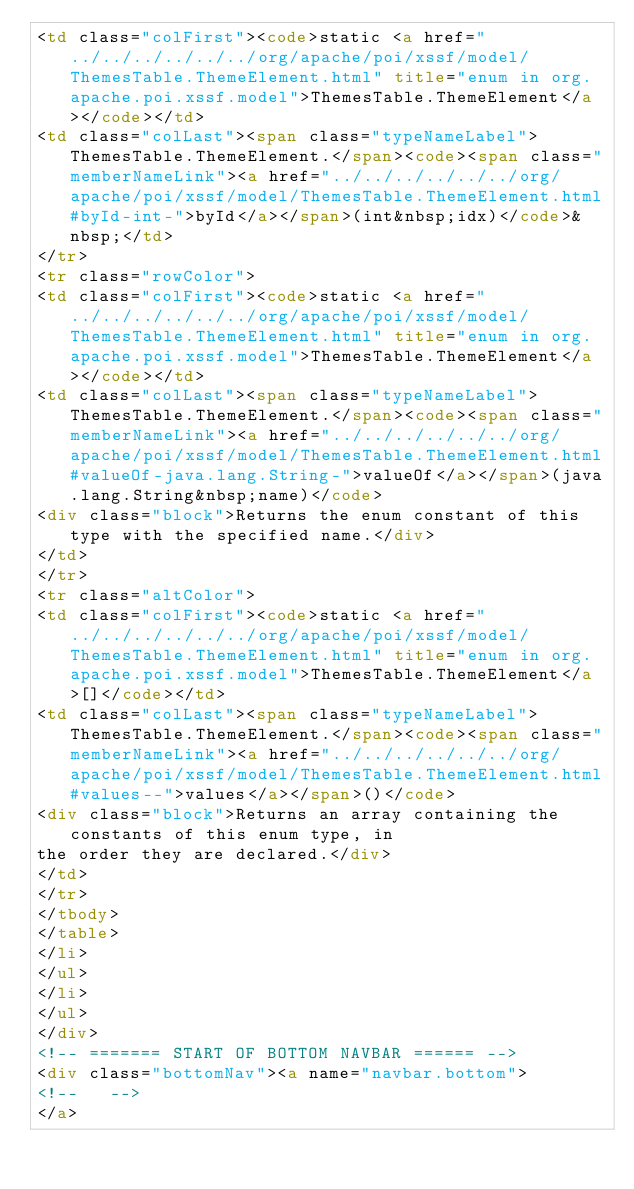Convert code to text. <code><loc_0><loc_0><loc_500><loc_500><_HTML_><td class="colFirst"><code>static <a href="../../../../../../org/apache/poi/xssf/model/ThemesTable.ThemeElement.html" title="enum in org.apache.poi.xssf.model">ThemesTable.ThemeElement</a></code></td>
<td class="colLast"><span class="typeNameLabel">ThemesTable.ThemeElement.</span><code><span class="memberNameLink"><a href="../../../../../../org/apache/poi/xssf/model/ThemesTable.ThemeElement.html#byId-int-">byId</a></span>(int&nbsp;idx)</code>&nbsp;</td>
</tr>
<tr class="rowColor">
<td class="colFirst"><code>static <a href="../../../../../../org/apache/poi/xssf/model/ThemesTable.ThemeElement.html" title="enum in org.apache.poi.xssf.model">ThemesTable.ThemeElement</a></code></td>
<td class="colLast"><span class="typeNameLabel">ThemesTable.ThemeElement.</span><code><span class="memberNameLink"><a href="../../../../../../org/apache/poi/xssf/model/ThemesTable.ThemeElement.html#valueOf-java.lang.String-">valueOf</a></span>(java.lang.String&nbsp;name)</code>
<div class="block">Returns the enum constant of this type with the specified name.</div>
</td>
</tr>
<tr class="altColor">
<td class="colFirst"><code>static <a href="../../../../../../org/apache/poi/xssf/model/ThemesTable.ThemeElement.html" title="enum in org.apache.poi.xssf.model">ThemesTable.ThemeElement</a>[]</code></td>
<td class="colLast"><span class="typeNameLabel">ThemesTable.ThemeElement.</span><code><span class="memberNameLink"><a href="../../../../../../org/apache/poi/xssf/model/ThemesTable.ThemeElement.html#values--">values</a></span>()</code>
<div class="block">Returns an array containing the constants of this enum type, in
the order they are declared.</div>
</td>
</tr>
</tbody>
</table>
</li>
</ul>
</li>
</ul>
</div>
<!-- ======= START OF BOTTOM NAVBAR ====== -->
<div class="bottomNav"><a name="navbar.bottom">
<!--   -->
</a></code> 